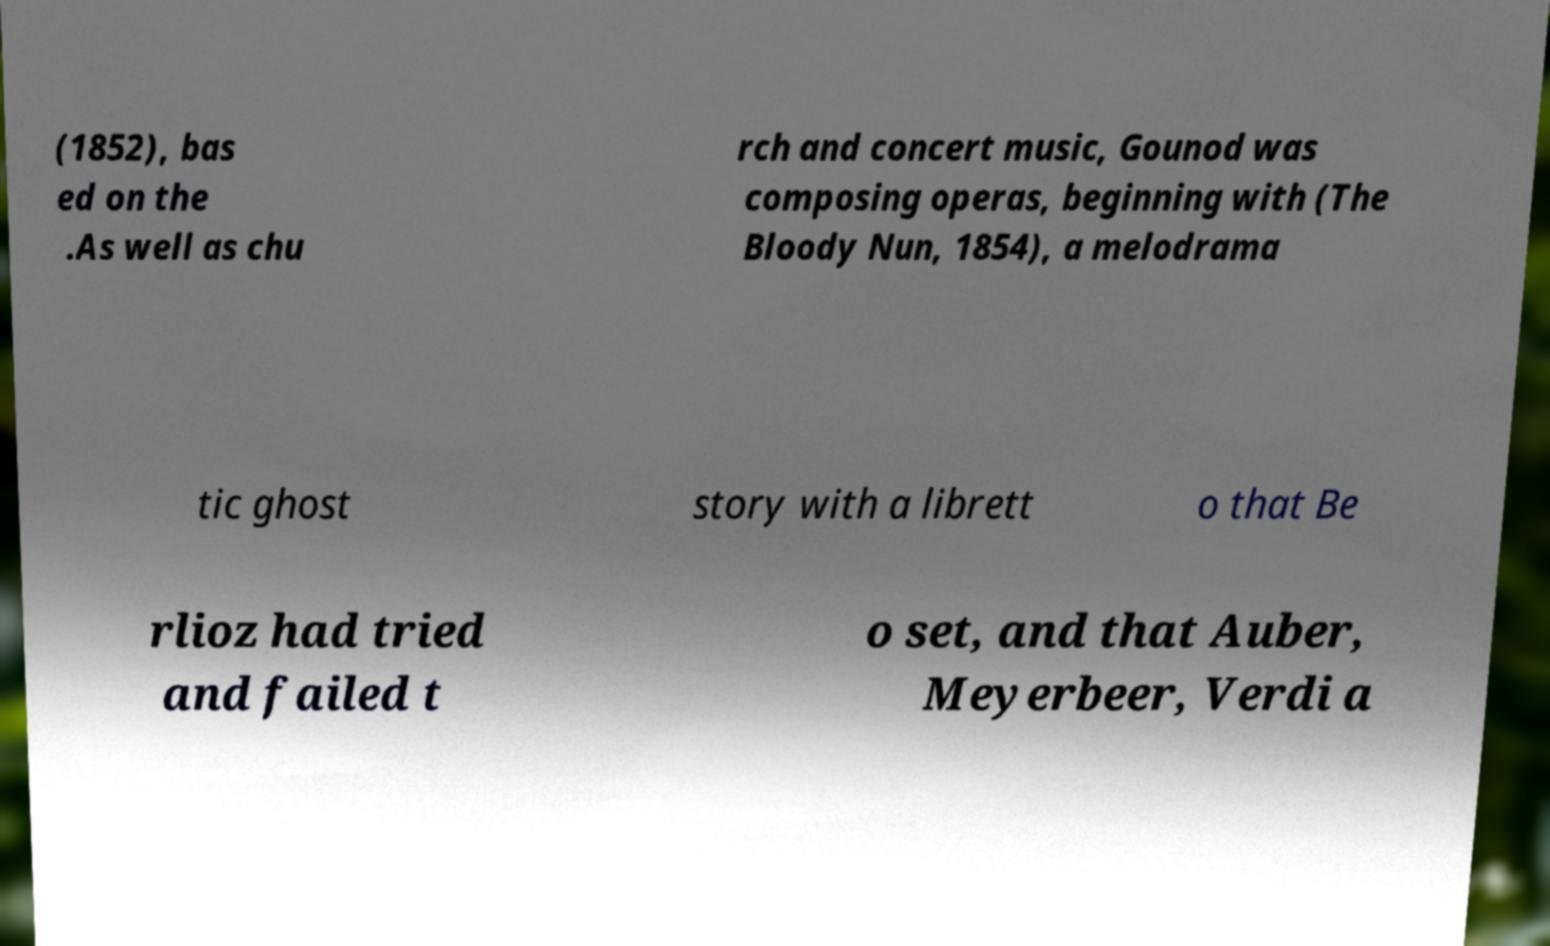For documentation purposes, I need the text within this image transcribed. Could you provide that? (1852), bas ed on the .As well as chu rch and concert music, Gounod was composing operas, beginning with (The Bloody Nun, 1854), a melodrama tic ghost story with a librett o that Be rlioz had tried and failed t o set, and that Auber, Meyerbeer, Verdi a 